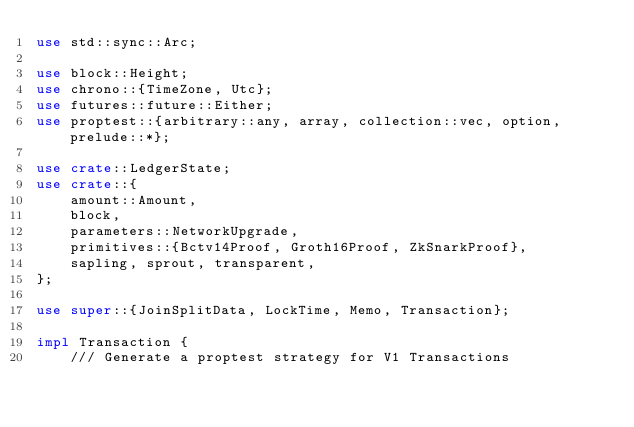Convert code to text. <code><loc_0><loc_0><loc_500><loc_500><_Rust_>use std::sync::Arc;

use block::Height;
use chrono::{TimeZone, Utc};
use futures::future::Either;
use proptest::{arbitrary::any, array, collection::vec, option, prelude::*};

use crate::LedgerState;
use crate::{
    amount::Amount,
    block,
    parameters::NetworkUpgrade,
    primitives::{Bctv14Proof, Groth16Proof, ZkSnarkProof},
    sapling, sprout, transparent,
};

use super::{JoinSplitData, LockTime, Memo, Transaction};

impl Transaction {
    /// Generate a proptest strategy for V1 Transactions</code> 